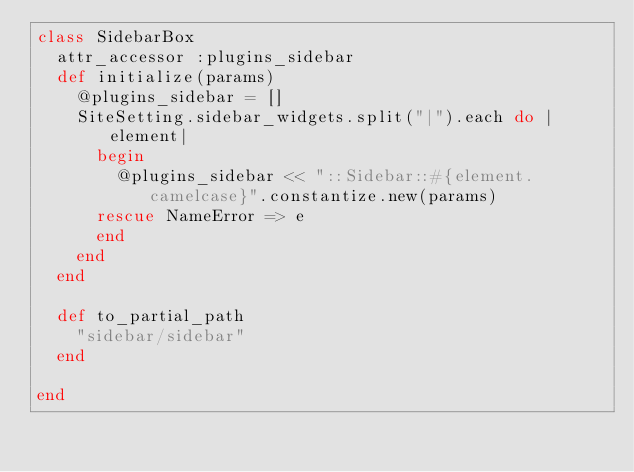<code> <loc_0><loc_0><loc_500><loc_500><_Ruby_>class SidebarBox
  attr_accessor :plugins_sidebar
  def initialize(params)
    @plugins_sidebar = []
    SiteSetting.sidebar_widgets.split("|").each do |element|
      begin
        @plugins_sidebar << "::Sidebar::#{element.camelcase}".constantize.new(params)
      rescue NameError => e
      end
  	end
	end

	def to_partial_path
		"sidebar/sidebar"
  end

end</code> 